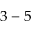<formula> <loc_0><loc_0><loc_500><loc_500>3 - 5</formula> 